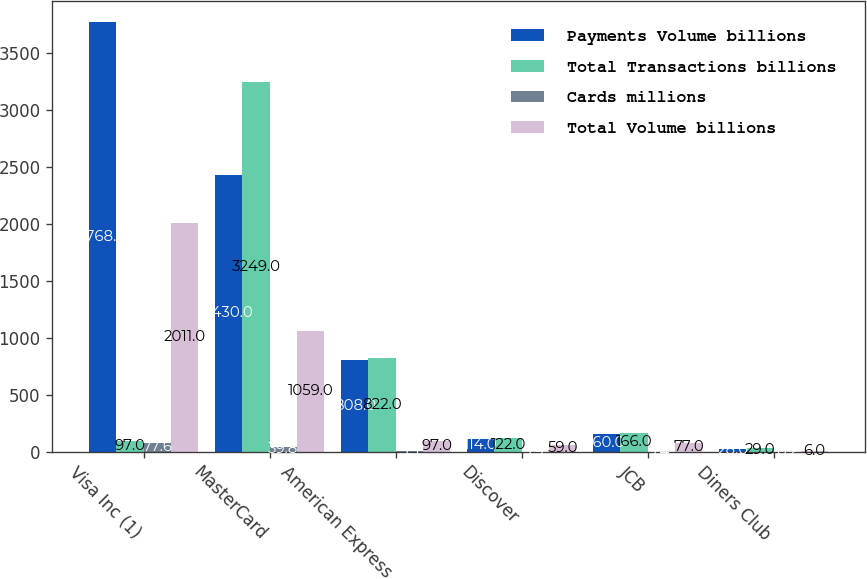<chart> <loc_0><loc_0><loc_500><loc_500><stacked_bar_chart><ecel><fcel>Visa Inc (1)<fcel>MasterCard<fcel>American Express<fcel>Discover<fcel>JCB<fcel>Diners Club<nl><fcel>Payments Volume billions<fcel>3768<fcel>2430<fcel>808<fcel>114<fcel>160<fcel>28<nl><fcel>Total Transactions billions<fcel>97<fcel>3249<fcel>822<fcel>122<fcel>166<fcel>29<nl><fcel>Cards millions<fcel>77.6<fcel>39.8<fcel>5.3<fcel>1.9<fcel>1.4<fcel>0.2<nl><fcel>Total Volume billions<fcel>2011<fcel>1059<fcel>97<fcel>59<fcel>77<fcel>6<nl></chart> 